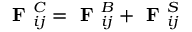Convert formula to latex. <formula><loc_0><loc_0><loc_500><loc_500>F _ { i j } ^ { C } = F _ { i j } ^ { B } + F _ { i j } ^ { S }</formula> 